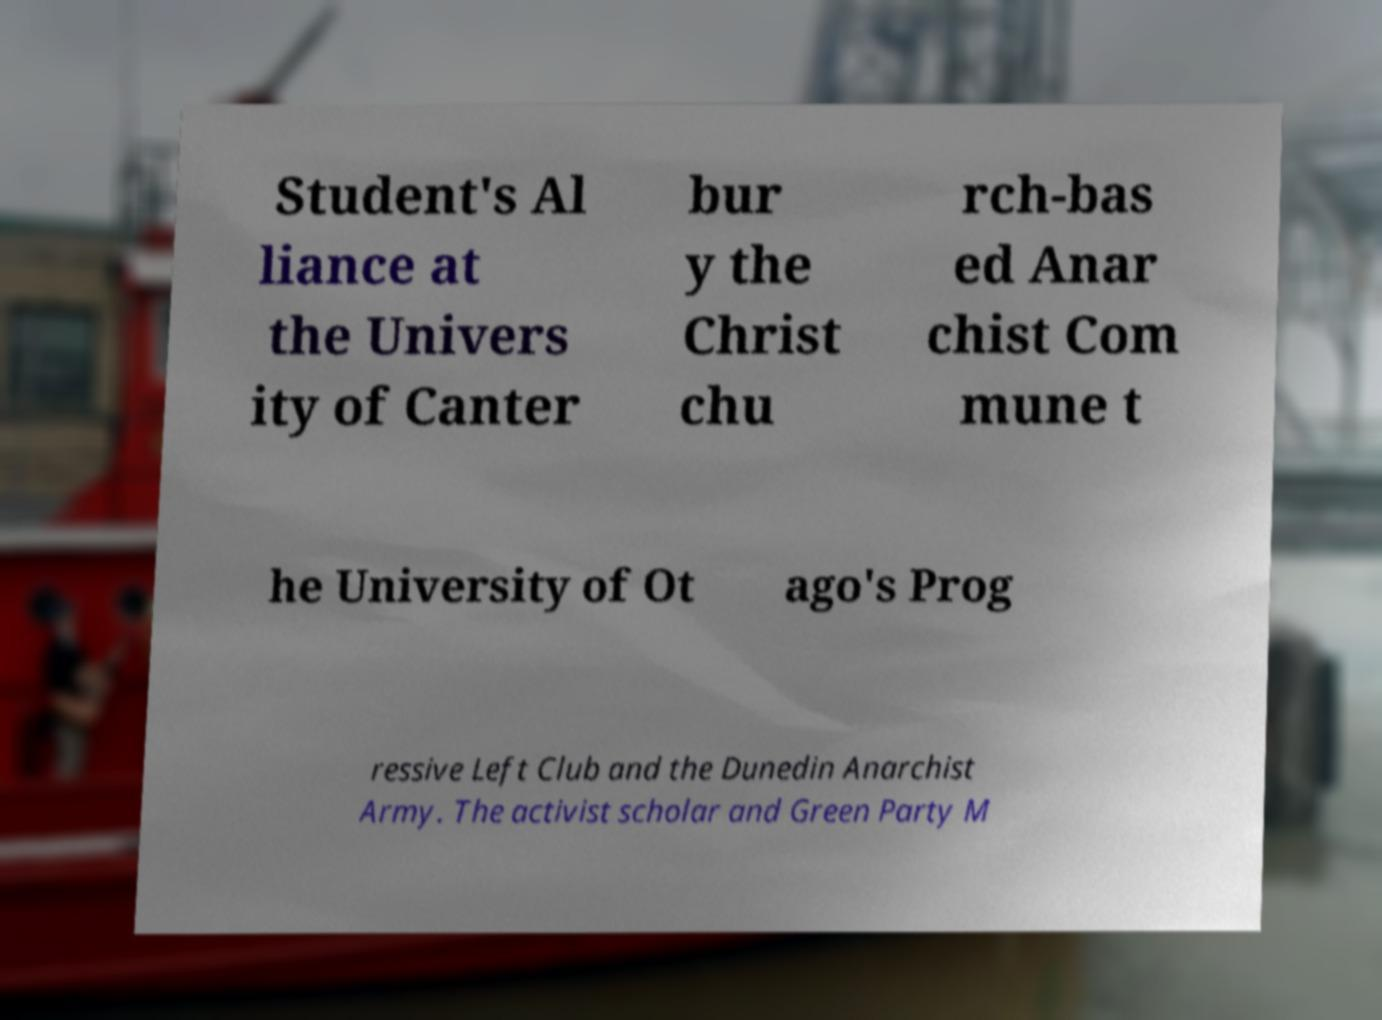What messages or text are displayed in this image? I need them in a readable, typed format. Student's Al liance at the Univers ity of Canter bur y the Christ chu rch-bas ed Anar chist Com mune t he University of Ot ago's Prog ressive Left Club and the Dunedin Anarchist Army. The activist scholar and Green Party M 